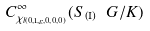<formula> <loc_0><loc_0><loc_500><loc_500>C ^ { \infty } _ { \chi _ { l ( 0 , 1 , \varepsilon , 0 , 0 , 0 ) } } ( S _ { \text {(I)} } \ G / K )</formula> 